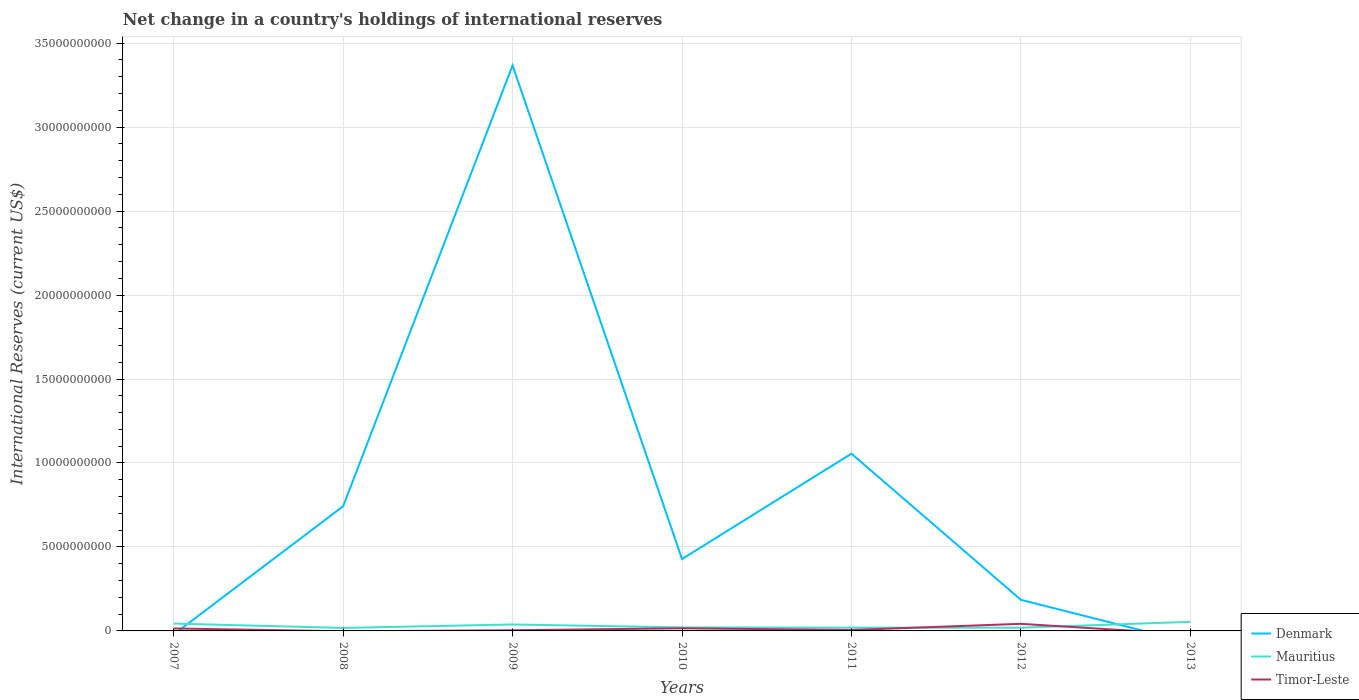How many different coloured lines are there?
Provide a succinct answer. 3. Is the number of lines equal to the number of legend labels?
Make the answer very short. No. What is the total international reserves in Denmark in the graph?
Give a very brief answer. 2.94e+1. What is the difference between the highest and the second highest international reserves in Denmark?
Make the answer very short. 3.37e+1. What is the difference between the highest and the lowest international reserves in Denmark?
Make the answer very short. 2. Is the international reserves in Mauritius strictly greater than the international reserves in Denmark over the years?
Your answer should be very brief. No. What is the difference between two consecutive major ticks on the Y-axis?
Ensure brevity in your answer.  5.00e+09. Are the values on the major ticks of Y-axis written in scientific E-notation?
Your answer should be compact. No. Where does the legend appear in the graph?
Your answer should be compact. Bottom right. How many legend labels are there?
Keep it short and to the point. 3. What is the title of the graph?
Your answer should be very brief. Net change in a country's holdings of international reserves. Does "El Salvador" appear as one of the legend labels in the graph?
Ensure brevity in your answer.  No. What is the label or title of the X-axis?
Provide a succinct answer. Years. What is the label or title of the Y-axis?
Give a very brief answer. International Reserves (current US$). What is the International Reserves (current US$) in Denmark in 2007?
Make the answer very short. 0. What is the International Reserves (current US$) in Mauritius in 2007?
Your response must be concise. 4.36e+08. What is the International Reserves (current US$) in Timor-Leste in 2007?
Provide a succinct answer. 1.47e+08. What is the International Reserves (current US$) of Denmark in 2008?
Keep it short and to the point. 7.42e+09. What is the International Reserves (current US$) in Mauritius in 2008?
Offer a very short reply. 1.78e+08. What is the International Reserves (current US$) in Timor-Leste in 2008?
Ensure brevity in your answer.  0. What is the International Reserves (current US$) of Denmark in 2009?
Provide a succinct answer. 3.37e+1. What is the International Reserves (current US$) in Mauritius in 2009?
Provide a succinct answer. 3.85e+08. What is the International Reserves (current US$) of Timor-Leste in 2009?
Your answer should be very brief. 3.95e+07. What is the International Reserves (current US$) of Denmark in 2010?
Make the answer very short. 4.28e+09. What is the International Reserves (current US$) of Mauritius in 2010?
Give a very brief answer. 2.09e+08. What is the International Reserves (current US$) of Timor-Leste in 2010?
Make the answer very short. 1.56e+08. What is the International Reserves (current US$) of Denmark in 2011?
Your answer should be very brief. 1.06e+1. What is the International Reserves (current US$) in Mauritius in 2011?
Your answer should be very brief. 1.95e+08. What is the International Reserves (current US$) of Timor-Leste in 2011?
Ensure brevity in your answer.  5.55e+07. What is the International Reserves (current US$) in Denmark in 2012?
Keep it short and to the point. 1.85e+09. What is the International Reserves (current US$) in Mauritius in 2012?
Provide a short and direct response. 1.92e+08. What is the International Reserves (current US$) of Timor-Leste in 2012?
Make the answer very short. 4.22e+08. What is the International Reserves (current US$) of Denmark in 2013?
Provide a succinct answer. 0. What is the International Reserves (current US$) of Mauritius in 2013?
Your response must be concise. 5.41e+08. Across all years, what is the maximum International Reserves (current US$) in Denmark?
Your answer should be compact. 3.37e+1. Across all years, what is the maximum International Reserves (current US$) of Mauritius?
Offer a terse response. 5.41e+08. Across all years, what is the maximum International Reserves (current US$) of Timor-Leste?
Keep it short and to the point. 4.22e+08. Across all years, what is the minimum International Reserves (current US$) in Denmark?
Offer a terse response. 0. Across all years, what is the minimum International Reserves (current US$) of Mauritius?
Offer a very short reply. 1.78e+08. What is the total International Reserves (current US$) of Denmark in the graph?
Ensure brevity in your answer.  5.78e+1. What is the total International Reserves (current US$) of Mauritius in the graph?
Provide a succinct answer. 2.14e+09. What is the total International Reserves (current US$) of Timor-Leste in the graph?
Keep it short and to the point. 8.20e+08. What is the difference between the International Reserves (current US$) of Mauritius in 2007 and that in 2008?
Make the answer very short. 2.58e+08. What is the difference between the International Reserves (current US$) of Mauritius in 2007 and that in 2009?
Ensure brevity in your answer.  5.14e+07. What is the difference between the International Reserves (current US$) in Timor-Leste in 2007 and that in 2009?
Your answer should be compact. 1.07e+08. What is the difference between the International Reserves (current US$) in Mauritius in 2007 and that in 2010?
Your answer should be compact. 2.27e+08. What is the difference between the International Reserves (current US$) in Timor-Leste in 2007 and that in 2010?
Provide a short and direct response. -9.96e+06. What is the difference between the International Reserves (current US$) of Mauritius in 2007 and that in 2011?
Give a very brief answer. 2.41e+08. What is the difference between the International Reserves (current US$) in Timor-Leste in 2007 and that in 2011?
Make the answer very short. 9.11e+07. What is the difference between the International Reserves (current US$) of Mauritius in 2007 and that in 2012?
Offer a very short reply. 2.44e+08. What is the difference between the International Reserves (current US$) of Timor-Leste in 2007 and that in 2012?
Ensure brevity in your answer.  -2.75e+08. What is the difference between the International Reserves (current US$) of Mauritius in 2007 and that in 2013?
Make the answer very short. -1.05e+08. What is the difference between the International Reserves (current US$) in Denmark in 2008 and that in 2009?
Keep it short and to the point. -2.62e+1. What is the difference between the International Reserves (current US$) in Mauritius in 2008 and that in 2009?
Offer a terse response. -2.07e+08. What is the difference between the International Reserves (current US$) of Denmark in 2008 and that in 2010?
Keep it short and to the point. 3.14e+09. What is the difference between the International Reserves (current US$) in Mauritius in 2008 and that in 2010?
Keep it short and to the point. -3.12e+07. What is the difference between the International Reserves (current US$) in Denmark in 2008 and that in 2011?
Keep it short and to the point. -3.13e+09. What is the difference between the International Reserves (current US$) of Mauritius in 2008 and that in 2011?
Offer a terse response. -1.72e+07. What is the difference between the International Reserves (current US$) of Denmark in 2008 and that in 2012?
Keep it short and to the point. 5.57e+09. What is the difference between the International Reserves (current US$) of Mauritius in 2008 and that in 2012?
Provide a succinct answer. -1.37e+07. What is the difference between the International Reserves (current US$) of Mauritius in 2008 and that in 2013?
Offer a terse response. -3.63e+08. What is the difference between the International Reserves (current US$) in Denmark in 2009 and that in 2010?
Provide a succinct answer. 2.94e+1. What is the difference between the International Reserves (current US$) of Mauritius in 2009 and that in 2010?
Provide a succinct answer. 1.76e+08. What is the difference between the International Reserves (current US$) in Timor-Leste in 2009 and that in 2010?
Your answer should be compact. -1.17e+08. What is the difference between the International Reserves (current US$) of Denmark in 2009 and that in 2011?
Keep it short and to the point. 2.31e+1. What is the difference between the International Reserves (current US$) of Mauritius in 2009 and that in 2011?
Your answer should be very brief. 1.90e+08. What is the difference between the International Reserves (current US$) of Timor-Leste in 2009 and that in 2011?
Make the answer very short. -1.60e+07. What is the difference between the International Reserves (current US$) in Denmark in 2009 and that in 2012?
Give a very brief answer. 3.18e+1. What is the difference between the International Reserves (current US$) in Mauritius in 2009 and that in 2012?
Give a very brief answer. 1.93e+08. What is the difference between the International Reserves (current US$) in Timor-Leste in 2009 and that in 2012?
Your response must be concise. -3.82e+08. What is the difference between the International Reserves (current US$) of Mauritius in 2009 and that in 2013?
Ensure brevity in your answer.  -1.56e+08. What is the difference between the International Reserves (current US$) of Denmark in 2010 and that in 2011?
Ensure brevity in your answer.  -6.27e+09. What is the difference between the International Reserves (current US$) of Mauritius in 2010 and that in 2011?
Provide a short and direct response. 1.39e+07. What is the difference between the International Reserves (current US$) in Timor-Leste in 2010 and that in 2011?
Give a very brief answer. 1.01e+08. What is the difference between the International Reserves (current US$) of Denmark in 2010 and that in 2012?
Ensure brevity in your answer.  2.43e+09. What is the difference between the International Reserves (current US$) of Mauritius in 2010 and that in 2012?
Offer a very short reply. 1.75e+07. What is the difference between the International Reserves (current US$) in Timor-Leste in 2010 and that in 2012?
Offer a terse response. -2.65e+08. What is the difference between the International Reserves (current US$) of Mauritius in 2010 and that in 2013?
Ensure brevity in your answer.  -3.32e+08. What is the difference between the International Reserves (current US$) of Denmark in 2011 and that in 2012?
Keep it short and to the point. 8.70e+09. What is the difference between the International Reserves (current US$) of Mauritius in 2011 and that in 2012?
Provide a succinct answer. 3.58e+06. What is the difference between the International Reserves (current US$) in Timor-Leste in 2011 and that in 2012?
Give a very brief answer. -3.66e+08. What is the difference between the International Reserves (current US$) of Mauritius in 2011 and that in 2013?
Your answer should be very brief. -3.46e+08. What is the difference between the International Reserves (current US$) of Mauritius in 2012 and that in 2013?
Your response must be concise. -3.49e+08. What is the difference between the International Reserves (current US$) of Mauritius in 2007 and the International Reserves (current US$) of Timor-Leste in 2009?
Keep it short and to the point. 3.97e+08. What is the difference between the International Reserves (current US$) in Mauritius in 2007 and the International Reserves (current US$) in Timor-Leste in 2010?
Ensure brevity in your answer.  2.80e+08. What is the difference between the International Reserves (current US$) in Mauritius in 2007 and the International Reserves (current US$) in Timor-Leste in 2011?
Keep it short and to the point. 3.81e+08. What is the difference between the International Reserves (current US$) of Mauritius in 2007 and the International Reserves (current US$) of Timor-Leste in 2012?
Offer a terse response. 1.41e+07. What is the difference between the International Reserves (current US$) of Denmark in 2008 and the International Reserves (current US$) of Mauritius in 2009?
Offer a terse response. 7.04e+09. What is the difference between the International Reserves (current US$) in Denmark in 2008 and the International Reserves (current US$) in Timor-Leste in 2009?
Make the answer very short. 7.38e+09. What is the difference between the International Reserves (current US$) of Mauritius in 2008 and the International Reserves (current US$) of Timor-Leste in 2009?
Offer a terse response. 1.38e+08. What is the difference between the International Reserves (current US$) of Denmark in 2008 and the International Reserves (current US$) of Mauritius in 2010?
Provide a succinct answer. 7.21e+09. What is the difference between the International Reserves (current US$) in Denmark in 2008 and the International Reserves (current US$) in Timor-Leste in 2010?
Provide a short and direct response. 7.27e+09. What is the difference between the International Reserves (current US$) of Mauritius in 2008 and the International Reserves (current US$) of Timor-Leste in 2010?
Give a very brief answer. 2.14e+07. What is the difference between the International Reserves (current US$) in Denmark in 2008 and the International Reserves (current US$) in Mauritius in 2011?
Offer a very short reply. 7.23e+09. What is the difference between the International Reserves (current US$) of Denmark in 2008 and the International Reserves (current US$) of Timor-Leste in 2011?
Make the answer very short. 7.37e+09. What is the difference between the International Reserves (current US$) in Mauritius in 2008 and the International Reserves (current US$) in Timor-Leste in 2011?
Your response must be concise. 1.22e+08. What is the difference between the International Reserves (current US$) of Denmark in 2008 and the International Reserves (current US$) of Mauritius in 2012?
Your answer should be very brief. 7.23e+09. What is the difference between the International Reserves (current US$) in Denmark in 2008 and the International Reserves (current US$) in Timor-Leste in 2012?
Make the answer very short. 7.00e+09. What is the difference between the International Reserves (current US$) of Mauritius in 2008 and the International Reserves (current US$) of Timor-Leste in 2012?
Keep it short and to the point. -2.44e+08. What is the difference between the International Reserves (current US$) in Denmark in 2008 and the International Reserves (current US$) in Mauritius in 2013?
Your response must be concise. 6.88e+09. What is the difference between the International Reserves (current US$) in Denmark in 2009 and the International Reserves (current US$) in Mauritius in 2010?
Give a very brief answer. 3.35e+1. What is the difference between the International Reserves (current US$) of Denmark in 2009 and the International Reserves (current US$) of Timor-Leste in 2010?
Offer a terse response. 3.35e+1. What is the difference between the International Reserves (current US$) of Mauritius in 2009 and the International Reserves (current US$) of Timor-Leste in 2010?
Your answer should be compact. 2.28e+08. What is the difference between the International Reserves (current US$) in Denmark in 2009 and the International Reserves (current US$) in Mauritius in 2011?
Provide a succinct answer. 3.35e+1. What is the difference between the International Reserves (current US$) of Denmark in 2009 and the International Reserves (current US$) of Timor-Leste in 2011?
Your answer should be compact. 3.36e+1. What is the difference between the International Reserves (current US$) of Mauritius in 2009 and the International Reserves (current US$) of Timor-Leste in 2011?
Offer a very short reply. 3.29e+08. What is the difference between the International Reserves (current US$) in Denmark in 2009 and the International Reserves (current US$) in Mauritius in 2012?
Your answer should be compact. 3.35e+1. What is the difference between the International Reserves (current US$) in Denmark in 2009 and the International Reserves (current US$) in Timor-Leste in 2012?
Your answer should be compact. 3.32e+1. What is the difference between the International Reserves (current US$) in Mauritius in 2009 and the International Reserves (current US$) in Timor-Leste in 2012?
Offer a very short reply. -3.73e+07. What is the difference between the International Reserves (current US$) in Denmark in 2009 and the International Reserves (current US$) in Mauritius in 2013?
Ensure brevity in your answer.  3.31e+1. What is the difference between the International Reserves (current US$) in Denmark in 2010 and the International Reserves (current US$) in Mauritius in 2011?
Offer a very short reply. 4.08e+09. What is the difference between the International Reserves (current US$) in Denmark in 2010 and the International Reserves (current US$) in Timor-Leste in 2011?
Give a very brief answer. 4.22e+09. What is the difference between the International Reserves (current US$) in Mauritius in 2010 and the International Reserves (current US$) in Timor-Leste in 2011?
Ensure brevity in your answer.  1.54e+08. What is the difference between the International Reserves (current US$) of Denmark in 2010 and the International Reserves (current US$) of Mauritius in 2012?
Provide a succinct answer. 4.09e+09. What is the difference between the International Reserves (current US$) of Denmark in 2010 and the International Reserves (current US$) of Timor-Leste in 2012?
Give a very brief answer. 3.86e+09. What is the difference between the International Reserves (current US$) in Mauritius in 2010 and the International Reserves (current US$) in Timor-Leste in 2012?
Your answer should be compact. -2.13e+08. What is the difference between the International Reserves (current US$) in Denmark in 2010 and the International Reserves (current US$) in Mauritius in 2013?
Provide a succinct answer. 3.74e+09. What is the difference between the International Reserves (current US$) in Denmark in 2011 and the International Reserves (current US$) in Mauritius in 2012?
Ensure brevity in your answer.  1.04e+1. What is the difference between the International Reserves (current US$) of Denmark in 2011 and the International Reserves (current US$) of Timor-Leste in 2012?
Your response must be concise. 1.01e+1. What is the difference between the International Reserves (current US$) of Mauritius in 2011 and the International Reserves (current US$) of Timor-Leste in 2012?
Ensure brevity in your answer.  -2.27e+08. What is the difference between the International Reserves (current US$) in Denmark in 2011 and the International Reserves (current US$) in Mauritius in 2013?
Your answer should be very brief. 1.00e+1. What is the difference between the International Reserves (current US$) of Denmark in 2012 and the International Reserves (current US$) of Mauritius in 2013?
Ensure brevity in your answer.  1.31e+09. What is the average International Reserves (current US$) of Denmark per year?
Your response must be concise. 8.25e+09. What is the average International Reserves (current US$) in Mauritius per year?
Provide a short and direct response. 3.05e+08. What is the average International Reserves (current US$) in Timor-Leste per year?
Your response must be concise. 1.17e+08. In the year 2007, what is the difference between the International Reserves (current US$) in Mauritius and International Reserves (current US$) in Timor-Leste?
Give a very brief answer. 2.90e+08. In the year 2008, what is the difference between the International Reserves (current US$) in Denmark and International Reserves (current US$) in Mauritius?
Provide a short and direct response. 7.24e+09. In the year 2009, what is the difference between the International Reserves (current US$) in Denmark and International Reserves (current US$) in Mauritius?
Provide a succinct answer. 3.33e+1. In the year 2009, what is the difference between the International Reserves (current US$) in Denmark and International Reserves (current US$) in Timor-Leste?
Give a very brief answer. 3.36e+1. In the year 2009, what is the difference between the International Reserves (current US$) in Mauritius and International Reserves (current US$) in Timor-Leste?
Ensure brevity in your answer.  3.45e+08. In the year 2010, what is the difference between the International Reserves (current US$) in Denmark and International Reserves (current US$) in Mauritius?
Your response must be concise. 4.07e+09. In the year 2010, what is the difference between the International Reserves (current US$) of Denmark and International Reserves (current US$) of Timor-Leste?
Your answer should be compact. 4.12e+09. In the year 2010, what is the difference between the International Reserves (current US$) in Mauritius and International Reserves (current US$) in Timor-Leste?
Provide a succinct answer. 5.26e+07. In the year 2011, what is the difference between the International Reserves (current US$) of Denmark and International Reserves (current US$) of Mauritius?
Provide a short and direct response. 1.04e+1. In the year 2011, what is the difference between the International Reserves (current US$) in Denmark and International Reserves (current US$) in Timor-Leste?
Your answer should be very brief. 1.05e+1. In the year 2011, what is the difference between the International Reserves (current US$) of Mauritius and International Reserves (current US$) of Timor-Leste?
Provide a succinct answer. 1.40e+08. In the year 2012, what is the difference between the International Reserves (current US$) of Denmark and International Reserves (current US$) of Mauritius?
Give a very brief answer. 1.66e+09. In the year 2012, what is the difference between the International Reserves (current US$) in Denmark and International Reserves (current US$) in Timor-Leste?
Provide a succinct answer. 1.43e+09. In the year 2012, what is the difference between the International Reserves (current US$) of Mauritius and International Reserves (current US$) of Timor-Leste?
Provide a short and direct response. -2.30e+08. What is the ratio of the International Reserves (current US$) of Mauritius in 2007 to that in 2008?
Offer a very short reply. 2.45. What is the ratio of the International Reserves (current US$) in Mauritius in 2007 to that in 2009?
Give a very brief answer. 1.13. What is the ratio of the International Reserves (current US$) in Timor-Leste in 2007 to that in 2009?
Your response must be concise. 3.71. What is the ratio of the International Reserves (current US$) in Mauritius in 2007 to that in 2010?
Keep it short and to the point. 2.09. What is the ratio of the International Reserves (current US$) of Timor-Leste in 2007 to that in 2010?
Offer a very short reply. 0.94. What is the ratio of the International Reserves (current US$) in Mauritius in 2007 to that in 2011?
Give a very brief answer. 2.23. What is the ratio of the International Reserves (current US$) of Timor-Leste in 2007 to that in 2011?
Provide a succinct answer. 2.64. What is the ratio of the International Reserves (current US$) of Mauritius in 2007 to that in 2012?
Make the answer very short. 2.28. What is the ratio of the International Reserves (current US$) of Timor-Leste in 2007 to that in 2012?
Your answer should be very brief. 0.35. What is the ratio of the International Reserves (current US$) of Mauritius in 2007 to that in 2013?
Give a very brief answer. 0.81. What is the ratio of the International Reserves (current US$) of Denmark in 2008 to that in 2009?
Provide a short and direct response. 0.22. What is the ratio of the International Reserves (current US$) in Mauritius in 2008 to that in 2009?
Your answer should be compact. 0.46. What is the ratio of the International Reserves (current US$) in Denmark in 2008 to that in 2010?
Your response must be concise. 1.73. What is the ratio of the International Reserves (current US$) in Mauritius in 2008 to that in 2010?
Your answer should be compact. 0.85. What is the ratio of the International Reserves (current US$) of Denmark in 2008 to that in 2011?
Keep it short and to the point. 0.7. What is the ratio of the International Reserves (current US$) in Mauritius in 2008 to that in 2011?
Give a very brief answer. 0.91. What is the ratio of the International Reserves (current US$) in Denmark in 2008 to that in 2012?
Make the answer very short. 4.01. What is the ratio of the International Reserves (current US$) of Mauritius in 2008 to that in 2012?
Provide a short and direct response. 0.93. What is the ratio of the International Reserves (current US$) in Mauritius in 2008 to that in 2013?
Offer a terse response. 0.33. What is the ratio of the International Reserves (current US$) of Denmark in 2009 to that in 2010?
Give a very brief answer. 7.87. What is the ratio of the International Reserves (current US$) of Mauritius in 2009 to that in 2010?
Provide a succinct answer. 1.84. What is the ratio of the International Reserves (current US$) in Timor-Leste in 2009 to that in 2010?
Ensure brevity in your answer.  0.25. What is the ratio of the International Reserves (current US$) of Denmark in 2009 to that in 2011?
Keep it short and to the point. 3.19. What is the ratio of the International Reserves (current US$) in Mauritius in 2009 to that in 2011?
Give a very brief answer. 1.97. What is the ratio of the International Reserves (current US$) of Timor-Leste in 2009 to that in 2011?
Ensure brevity in your answer.  0.71. What is the ratio of the International Reserves (current US$) in Denmark in 2009 to that in 2012?
Give a very brief answer. 18.18. What is the ratio of the International Reserves (current US$) of Mauritius in 2009 to that in 2012?
Provide a short and direct response. 2.01. What is the ratio of the International Reserves (current US$) in Timor-Leste in 2009 to that in 2012?
Offer a very short reply. 0.09. What is the ratio of the International Reserves (current US$) in Mauritius in 2009 to that in 2013?
Keep it short and to the point. 0.71. What is the ratio of the International Reserves (current US$) in Denmark in 2010 to that in 2011?
Your answer should be very brief. 0.41. What is the ratio of the International Reserves (current US$) in Mauritius in 2010 to that in 2011?
Provide a succinct answer. 1.07. What is the ratio of the International Reserves (current US$) of Timor-Leste in 2010 to that in 2011?
Offer a terse response. 2.82. What is the ratio of the International Reserves (current US$) in Denmark in 2010 to that in 2012?
Provide a succinct answer. 2.31. What is the ratio of the International Reserves (current US$) of Mauritius in 2010 to that in 2012?
Offer a very short reply. 1.09. What is the ratio of the International Reserves (current US$) of Timor-Leste in 2010 to that in 2012?
Your answer should be very brief. 0.37. What is the ratio of the International Reserves (current US$) in Mauritius in 2010 to that in 2013?
Your answer should be very brief. 0.39. What is the ratio of the International Reserves (current US$) of Denmark in 2011 to that in 2012?
Keep it short and to the point. 5.7. What is the ratio of the International Reserves (current US$) of Mauritius in 2011 to that in 2012?
Your answer should be compact. 1.02. What is the ratio of the International Reserves (current US$) in Timor-Leste in 2011 to that in 2012?
Keep it short and to the point. 0.13. What is the ratio of the International Reserves (current US$) of Mauritius in 2011 to that in 2013?
Offer a terse response. 0.36. What is the ratio of the International Reserves (current US$) in Mauritius in 2012 to that in 2013?
Provide a succinct answer. 0.35. What is the difference between the highest and the second highest International Reserves (current US$) of Denmark?
Offer a terse response. 2.31e+1. What is the difference between the highest and the second highest International Reserves (current US$) of Mauritius?
Offer a very short reply. 1.05e+08. What is the difference between the highest and the second highest International Reserves (current US$) in Timor-Leste?
Offer a very short reply. 2.65e+08. What is the difference between the highest and the lowest International Reserves (current US$) of Denmark?
Make the answer very short. 3.37e+1. What is the difference between the highest and the lowest International Reserves (current US$) of Mauritius?
Your response must be concise. 3.63e+08. What is the difference between the highest and the lowest International Reserves (current US$) of Timor-Leste?
Offer a very short reply. 4.22e+08. 